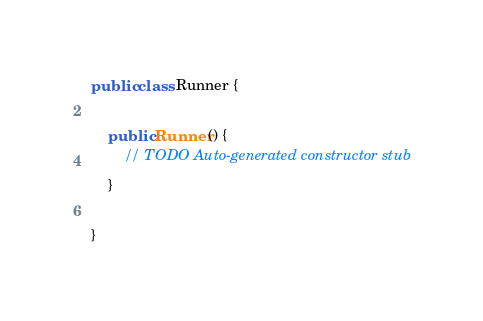<code> <loc_0><loc_0><loc_500><loc_500><_Java_>
public class Runner {

	public Runner() {
		// TODO Auto-generated constructor stub
	}

}
</code> 